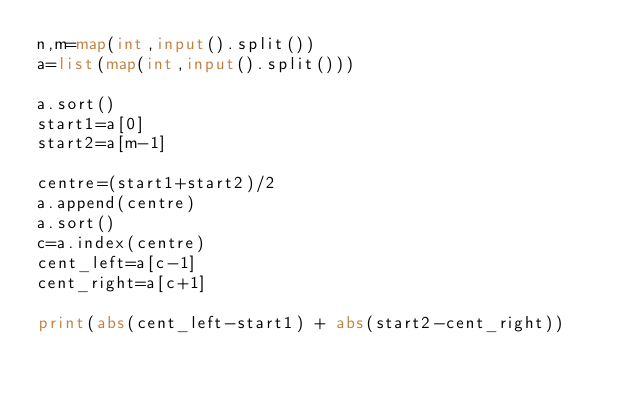<code> <loc_0><loc_0><loc_500><loc_500><_Python_>n,m=map(int,input().split())
a=list(map(int,input().split()))

a.sort()
start1=a[0]
start2=a[m-1]

centre=(start1+start2)/2
a.append(centre)
a.sort()
c=a.index(centre)
cent_left=a[c-1]
cent_right=a[c+1]

print(abs(cent_left-start1) + abs(start2-cent_right))</code> 